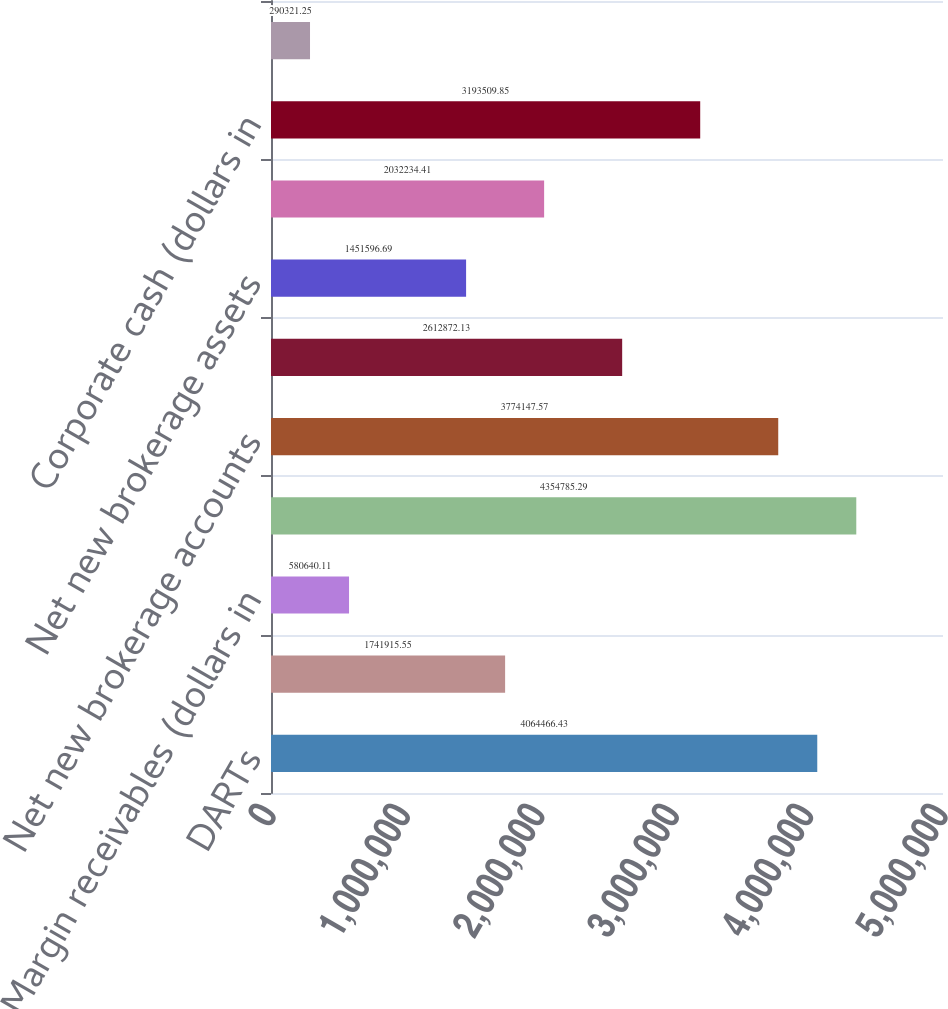Convert chart. <chart><loc_0><loc_0><loc_500><loc_500><bar_chart><fcel>DARTs<fcel>Average commission per trade<fcel>Margin receivables (dollars in<fcel>End of period brokerage<fcel>Net new brokerage accounts<fcel>Customer assets (dollars in<fcel>Net new brokerage assets<fcel>Brokerage related cash<fcel>Corporate cash (dollars in<fcel>ETRADE Financial Tier 1<nl><fcel>4.06447e+06<fcel>1.74192e+06<fcel>580640<fcel>4.35479e+06<fcel>3.77415e+06<fcel>2.61287e+06<fcel>1.4516e+06<fcel>2.03223e+06<fcel>3.19351e+06<fcel>290321<nl></chart> 